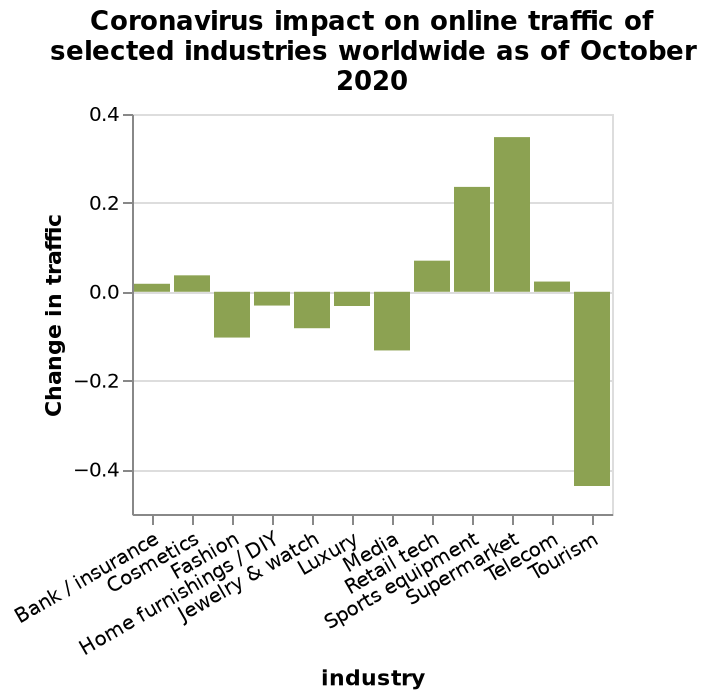<image>
please enumerates aspects of the construction of the chart This is a bar diagram labeled Coronavirus impact on online traffic of selected industries worldwide as of October 2020. The y-axis plots Change in traffic as categorical scale starting at −0.4 and ending at 0.4 while the x-axis measures industry using categorical scale starting at Bank / insurance and ending at Tourism. What does the bar diagram depict about the industries? The bar diagram demonstrates the comparative impact of the Coronavirus on online traffic across various industries, ranging from Bank / insurance to Tourism. What is the range of values represented on the y-axis? The y-axis ranges from -0.4 to 0.4, representing the Change in traffic on a categorical scale. 